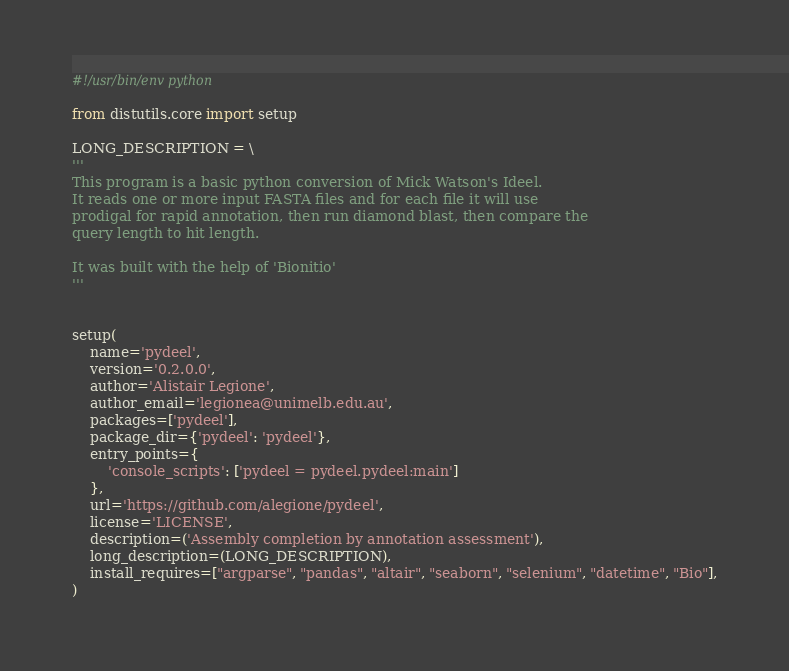<code> <loc_0><loc_0><loc_500><loc_500><_Python_>#!/usr/bin/env python

from distutils.core import setup

LONG_DESCRIPTION = \
'''
This program is a basic python conversion of Mick Watson's Ideel.
It reads one or more input FASTA files and for each file it will use
prodigal for rapid annotation, then run diamond blast, then compare the
query length to hit length.

It was built with the help of 'Bionitio'
'''


setup(
    name='pydeel',
    version='0.2.0.0',
    author='Alistair Legione',
    author_email='legionea@unimelb.edu.au',
    packages=['pydeel'],
    package_dir={'pydeel': 'pydeel'},
    entry_points={
        'console_scripts': ['pydeel = pydeel.pydeel:main']
    },
    url='https://github.com/alegione/pydeel',
    license='LICENSE',
    description=('Assembly completion by annotation assessment'),
    long_description=(LONG_DESCRIPTION),
    install_requires=["argparse", "pandas", "altair", "seaborn", "selenium", "datetime", "Bio"],
)
</code> 